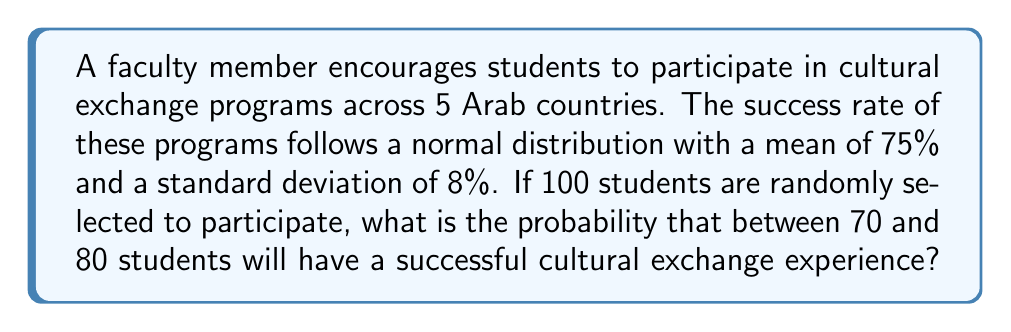Can you answer this question? Let's approach this step-by-step:

1) We are dealing with a binomial distribution that can be approximated by a normal distribution due to the large sample size (n = 100).

2) Let X be the number of successful exchanges. We need to find P(70 ≤ X ≤ 80).

3) The mean of this distribution is:
   $$\mu = np = 100 \cdot 0.75 = 75$$

4) The standard deviation is:
   $$\sigma = \sqrt{np(1-p)} = \sqrt{100 \cdot 0.75 \cdot 0.25} = \sqrt{18.75} \approx 4.33$$

5) We need to standardize our values:
   For X = 70: $$z_1 = \frac{70 - 75}{4.33} \approx -1.15$$
   For X = 80: $$z_2 = \frac{80 - 75}{4.33} \approx 1.15$$

6) Now we need to find P(-1.15 ≤ Z ≤ 1.15)

7) Using the standard normal distribution table:
   P(Z ≤ 1.15) ≈ 0.8749
   P(Z ≤ -1.15) ≈ 0.1251

8) Therefore:
   P(-1.15 ≤ Z ≤ 1.15) = P(Z ≤ 1.15) - P(Z ≤ -1.15)
                        ≈ 0.8749 - 0.1251 = 0.7498
Answer: 0.7498 